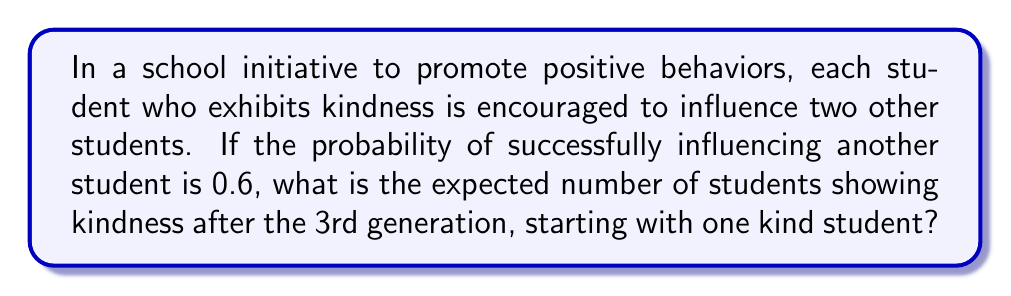Provide a solution to this math problem. Let's approach this problem using a branching process model:

1) First, we need to calculate the expected number of "offspring" (influenced students) for each student:
   $$ m = 2 \cdot 0.6 = 1.2 $$

2) In a branching process, the expected number of individuals in the nth generation is given by:
   $$ E[X_n] = m^n $$
   where $m$ is the expected number of offspring per individual and $n$ is the generation number.

3) We're interested in the 3rd generation (n = 3), so:
   $$ E[X_3] = 1.2^3 = 1.728 $$

4) However, this only gives us the expected number in the 3rd generation. To find the total expected number after the 3rd generation, we need to sum the expected numbers for all generations up to and including the 3rd:
   $$ E[Total] = 1 + 1.2 + 1.2^2 + 1.2^3 $$

5) This is a geometric series with first term $a = 1$ and common ratio $r = 1.2$. The sum of a geometric series is given by:
   $$ S_n = \frac{a(1-r^{n+1})}{1-r} $$
   where $n$ is one less than the number of terms (as we start with the 0th generation).

6) Plugging in our values:
   $$ S_3 = \frac{1(1-1.2^4)}{1-1.2} = \frac{1-2.0736}{-0.2} = 5.368 $$

Therefore, the expected total number of students showing kindness after the 3rd generation is approximately 5.368.
Answer: 5.368 students 